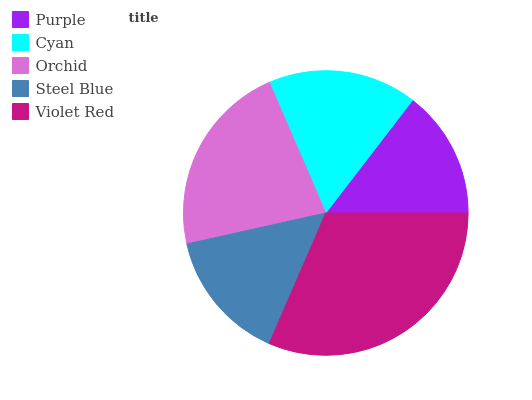Is Purple the minimum?
Answer yes or no. Yes. Is Violet Red the maximum?
Answer yes or no. Yes. Is Cyan the minimum?
Answer yes or no. No. Is Cyan the maximum?
Answer yes or no. No. Is Cyan greater than Purple?
Answer yes or no. Yes. Is Purple less than Cyan?
Answer yes or no. Yes. Is Purple greater than Cyan?
Answer yes or no. No. Is Cyan less than Purple?
Answer yes or no. No. Is Cyan the high median?
Answer yes or no. Yes. Is Cyan the low median?
Answer yes or no. Yes. Is Purple the high median?
Answer yes or no. No. Is Purple the low median?
Answer yes or no. No. 